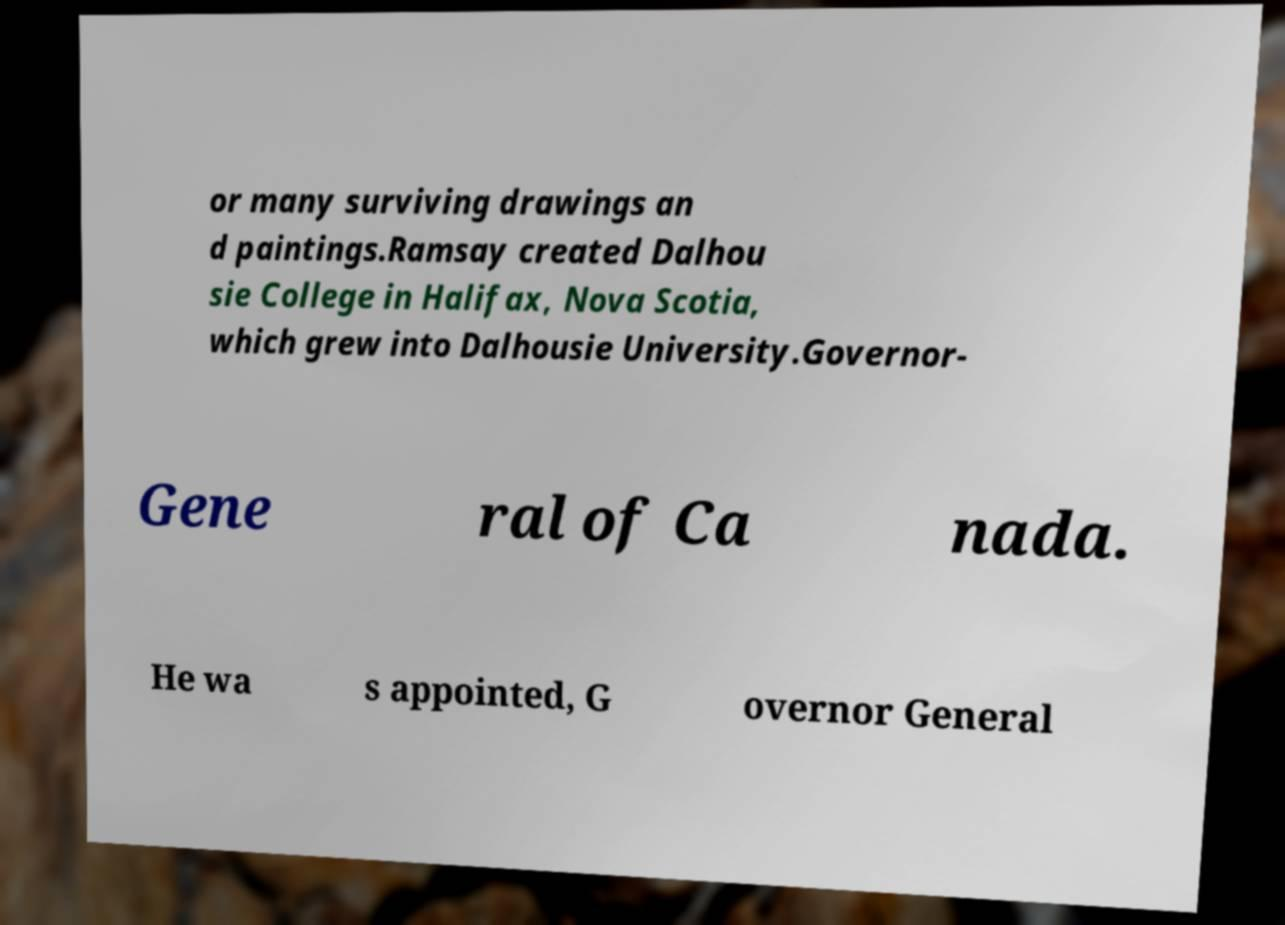Please identify and transcribe the text found in this image. or many surviving drawings an d paintings.Ramsay created Dalhou sie College in Halifax, Nova Scotia, which grew into Dalhousie University.Governor- Gene ral of Ca nada. He wa s appointed, G overnor General 